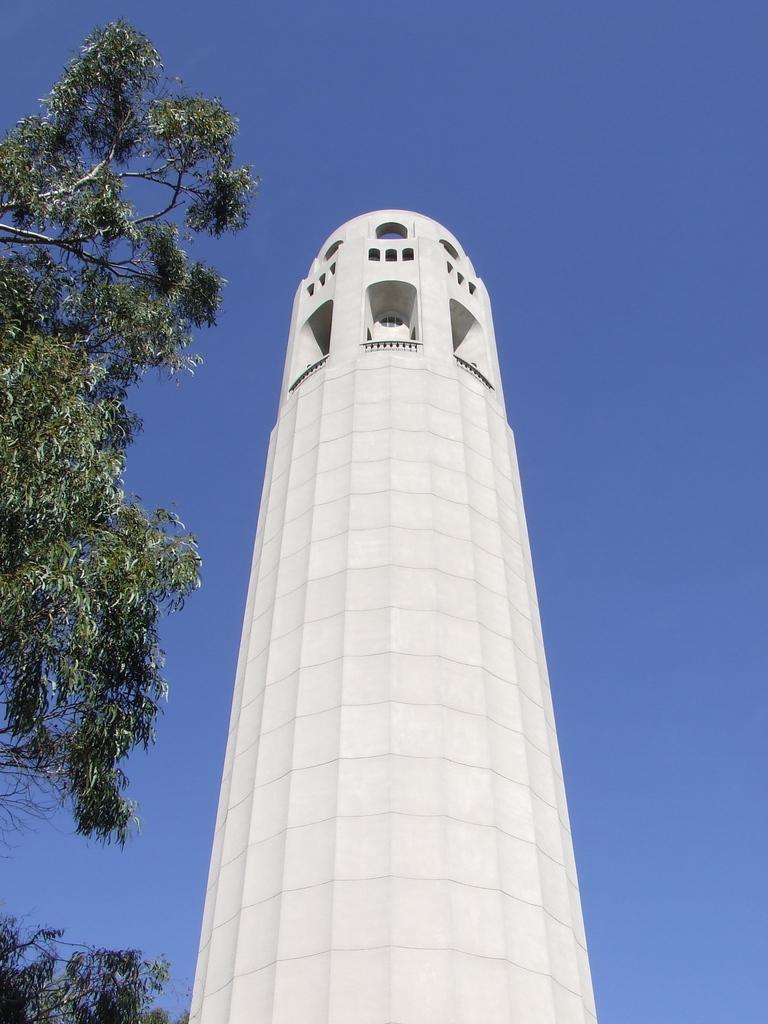Could you give a brief overview of what you see in this image? This is the picture of a tower. In this image there is a tower in the foreground. On the left side of the image there are trees. At the top there is sky. 